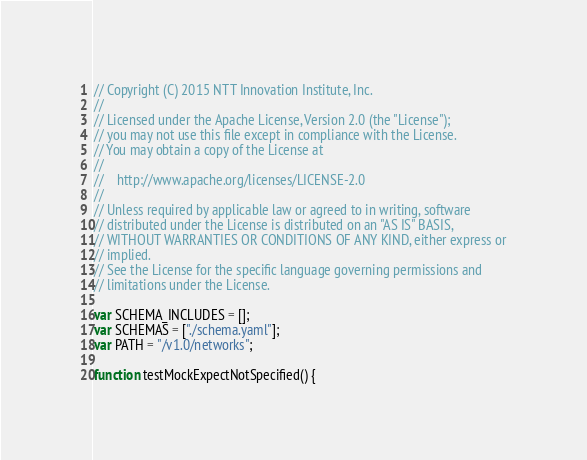<code> <loc_0><loc_0><loc_500><loc_500><_JavaScript_>// Copyright (C) 2015 NTT Innovation Institute, Inc.
//
// Licensed under the Apache License, Version 2.0 (the "License");
// you may not use this file except in compliance with the License.
// You may obtain a copy of the License at
//
//    http://www.apache.org/licenses/LICENSE-2.0
//
// Unless required by applicable law or agreed to in writing, software
// distributed under the License is distributed on an "AS IS" BASIS,
// WITHOUT WARRANTIES OR CONDITIONS OF ANY KIND, either express or
// implied.
// See the License for the specific language governing permissions and
// limitations under the License.

var SCHEMA_INCLUDES = [];
var SCHEMAS = ["./schema.yaml"];
var PATH = "/v1.0/networks";

function testMockExpectNotSpecified() {</code> 